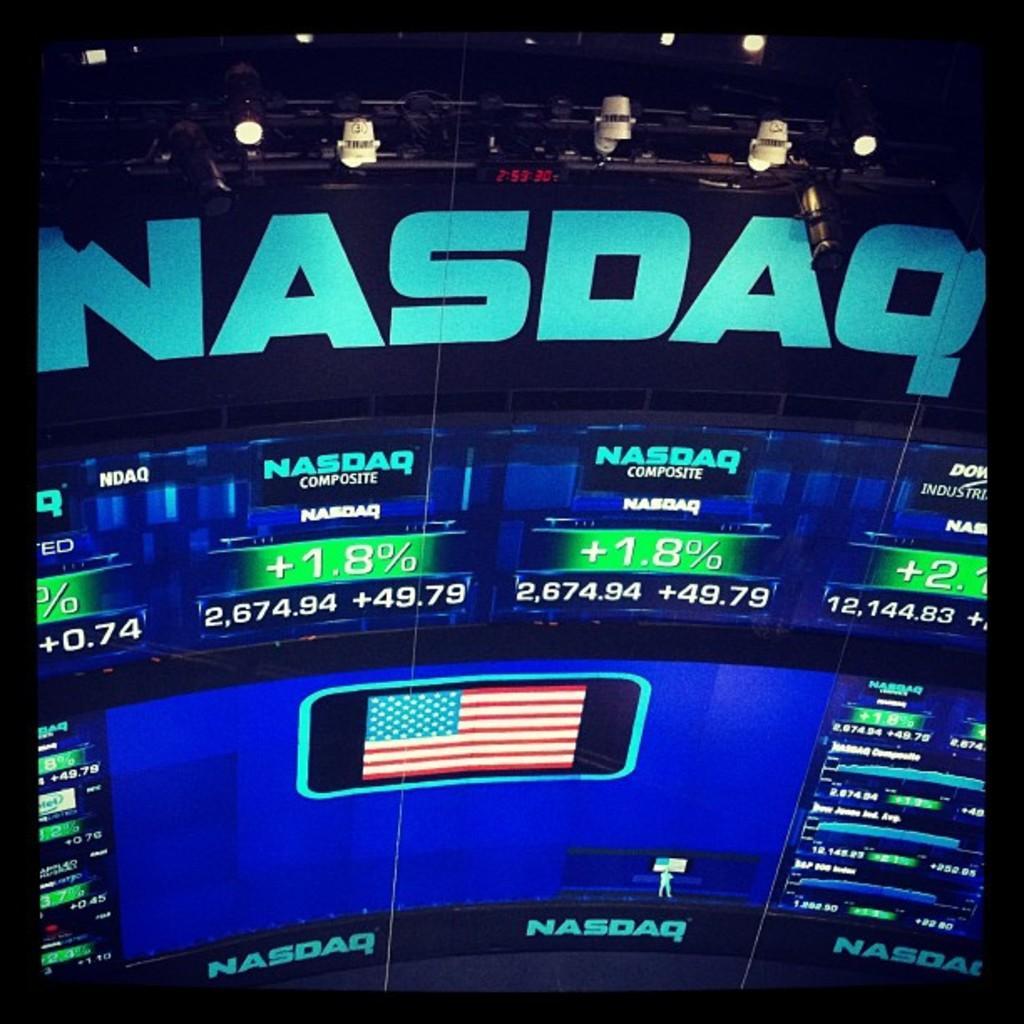Describe this image in one or two sentences. In this picture we can see a screen,on this screen we can see some text,numbers and a flag symbol. 